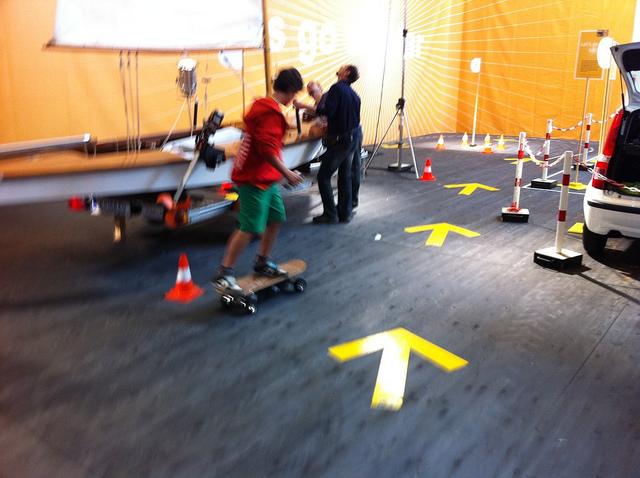Is the skateboarder going in the same direction as the arrows?
Short answer required. Yes. From what material is the floor made?
Quick response, please. Wood. What are the arrows for?
Quick response, please. Direction. 